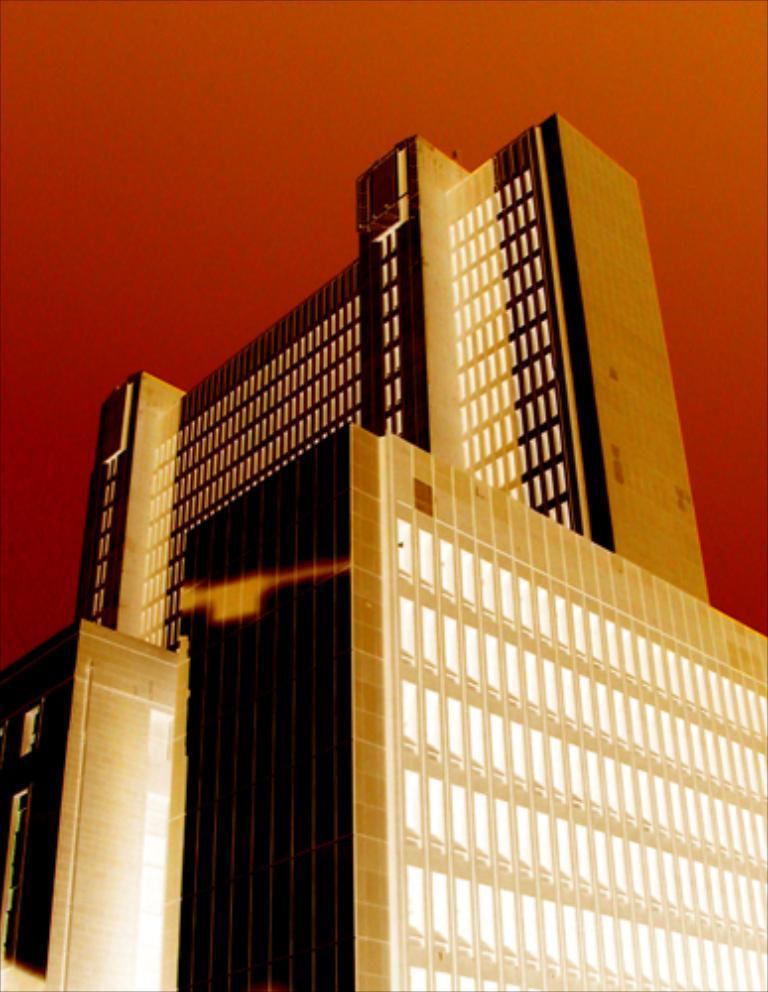What type of animation is used in the image? The image is an animated picture, but the specific type of animation cannot be determined from the provided facts. What is the main subject in the foreground of the image? There is a skyscraper in the foreground of the image. What color is the top part of the skyscraper? The top of the skyscraper is red. What type of alarm is ringing in the image? There is no alarm present in the image. What is the hammer being used for in the image? There is no hammer present in the image. 